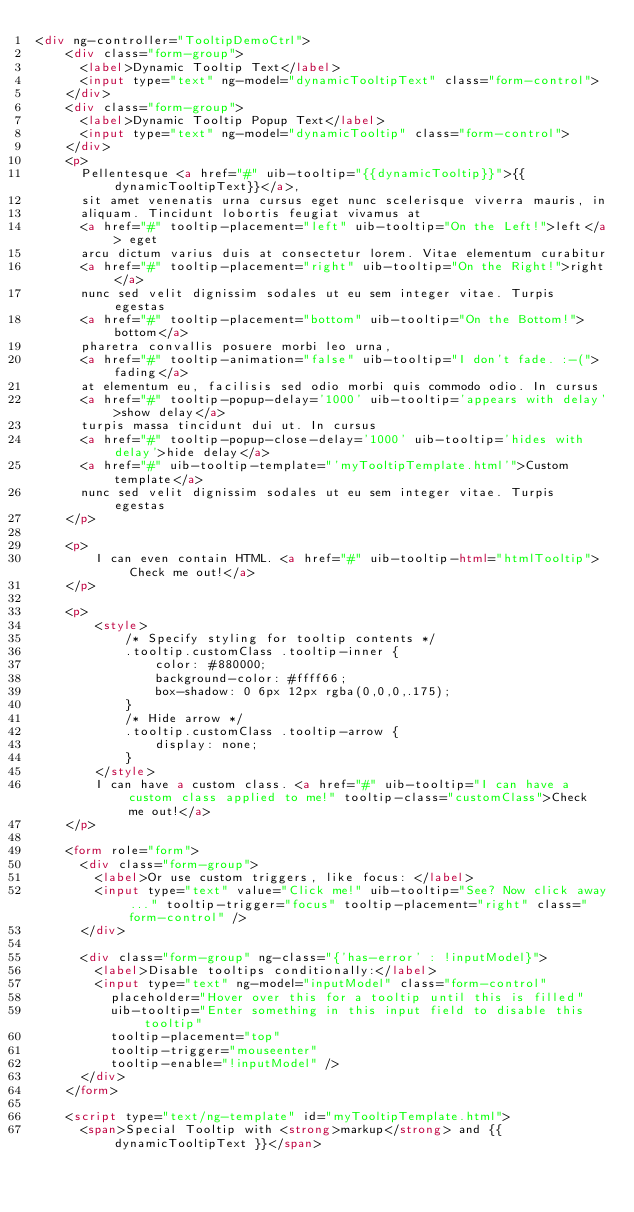Convert code to text. <code><loc_0><loc_0><loc_500><loc_500><_HTML_><div ng-controller="TooltipDemoCtrl">
    <div class="form-group">
      <label>Dynamic Tooltip Text</label>
      <input type="text" ng-model="dynamicTooltipText" class="form-control">
    </div>
    <div class="form-group">
      <label>Dynamic Tooltip Popup Text</label>
      <input type="text" ng-model="dynamicTooltip" class="form-control">
    </div>
    <p>
      Pellentesque <a href="#" uib-tooltip="{{dynamicTooltip}}">{{dynamicTooltipText}}</a>,
      sit amet venenatis urna cursus eget nunc scelerisque viverra mauris, in
      aliquam. Tincidunt lobortis feugiat vivamus at
      <a href="#" tooltip-placement="left" uib-tooltip="On the Left!">left</a> eget
      arcu dictum varius duis at consectetur lorem. Vitae elementum curabitur
      <a href="#" tooltip-placement="right" uib-tooltip="On the Right!">right</a>
      nunc sed velit dignissim sodales ut eu sem integer vitae. Turpis egestas
      <a href="#" tooltip-placement="bottom" uib-tooltip="On the Bottom!">bottom</a>
      pharetra convallis posuere morbi leo urna,
      <a href="#" tooltip-animation="false" uib-tooltip="I don't fade. :-(">fading</a>
      at elementum eu, facilisis sed odio morbi quis commodo odio. In cursus
      <a href="#" tooltip-popup-delay='1000' uib-tooltip='appears with delay'>show delay</a>
      turpis massa tincidunt dui ut. In cursus
      <a href="#" tooltip-popup-close-delay='1000' uib-tooltip='hides with delay'>hide delay</a>
      <a href="#" uib-tooltip-template="'myTooltipTemplate.html'">Custom template</a>
      nunc sed velit dignissim sodales ut eu sem integer vitae. Turpis egestas
    </p>

    <p>
        I can even contain HTML. <a href="#" uib-tooltip-html="htmlTooltip">Check me out!</a>
    </p>

    <p>
        <style>
            /* Specify styling for tooltip contents */
            .tooltip.customClass .tooltip-inner {
                color: #880000;
                background-color: #ffff66;
                box-shadow: 0 6px 12px rgba(0,0,0,.175);
            }
            /* Hide arrow */
            .tooltip.customClass .tooltip-arrow {
                display: none;
            }
        </style>
        I can have a custom class. <a href="#" uib-tooltip="I can have a custom class applied to me!" tooltip-class="customClass">Check me out!</a>
    </p>

    <form role="form">
      <div class="form-group">
        <label>Or use custom triggers, like focus: </label>
        <input type="text" value="Click me!" uib-tooltip="See? Now click away..." tooltip-trigger="focus" tooltip-placement="right" class="form-control" />
      </div>

      <div class="form-group" ng-class="{'has-error' : !inputModel}">
        <label>Disable tooltips conditionally:</label>
        <input type="text" ng-model="inputModel" class="form-control"
          placeholder="Hover over this for a tooltip until this is filled"
          uib-tooltip="Enter something in this input field to disable this tooltip"
          tooltip-placement="top"
          tooltip-trigger="mouseenter"
          tooltip-enable="!inputModel" />
      </div>
    </form>

    <script type="text/ng-template" id="myTooltipTemplate.html">
      <span>Special Tooltip with <strong>markup</strong> and {{ dynamicTooltipText }}</span></code> 